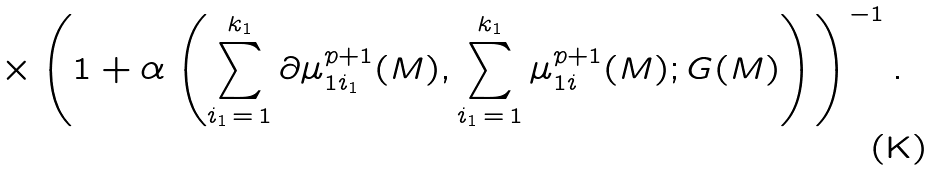Convert formula to latex. <formula><loc_0><loc_0><loc_500><loc_500>\times \left ( 1 + \alpha \left ( \sum _ { i _ { 1 } \, = \, 1 } ^ { k _ { 1 } } \partial \mu _ { 1 i _ { 1 } } ^ { p + 1 } ( M ) , \sum _ { i _ { 1 } \, = \, 1 } ^ { k _ { 1 } } \mu _ { 1 i } ^ { p + 1 } ( M ) ; G ( M ) \right ) \right ) ^ { - 1 } .</formula> 